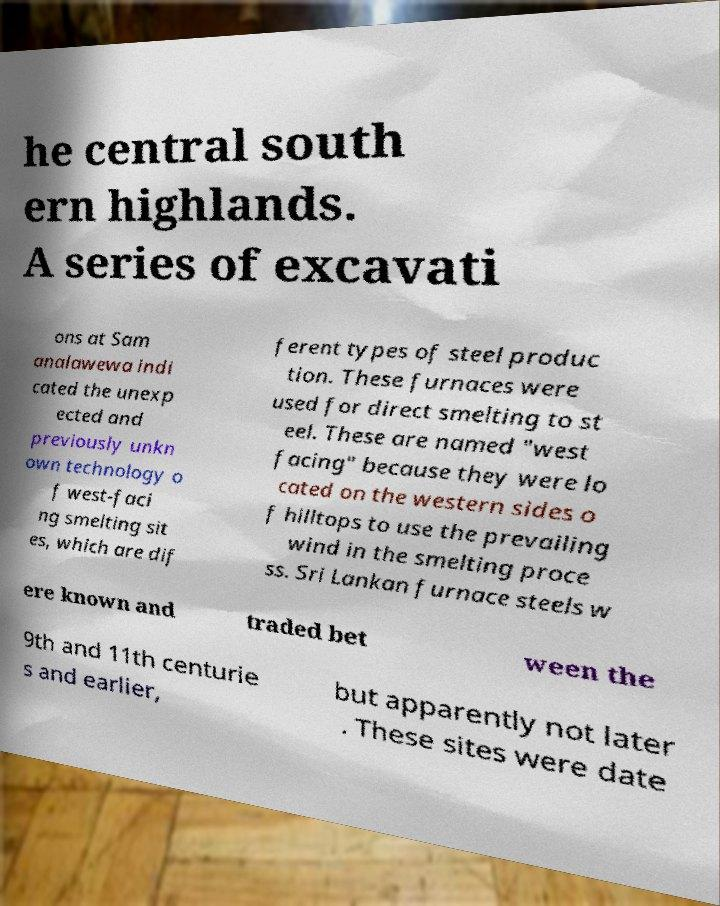Could you assist in decoding the text presented in this image and type it out clearly? he central south ern highlands. A series of excavati ons at Sam analawewa indi cated the unexp ected and previously unkn own technology o f west-faci ng smelting sit es, which are dif ferent types of steel produc tion. These furnaces were used for direct smelting to st eel. These are named "west facing" because they were lo cated on the western sides o f hilltops to use the prevailing wind in the smelting proce ss. Sri Lankan furnace steels w ere known and traded bet ween the 9th and 11th centurie s and earlier, but apparently not later . These sites were date 